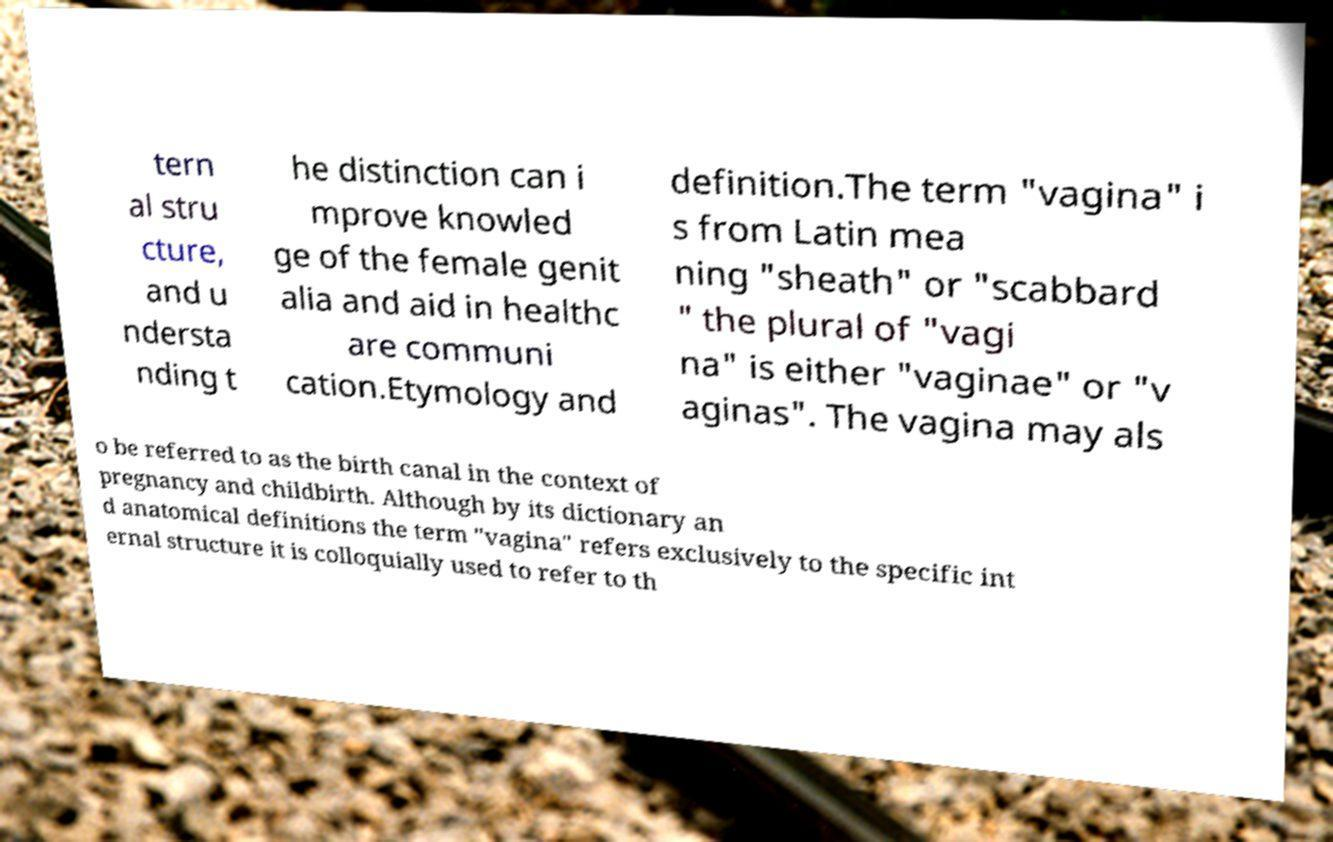What messages or text are displayed in this image? I need them in a readable, typed format. tern al stru cture, and u ndersta nding t he distinction can i mprove knowled ge of the female genit alia and aid in healthc are communi cation.Etymology and definition.The term "vagina" i s from Latin mea ning "sheath" or "scabbard " the plural of "vagi na" is either "vaginae" or "v aginas". The vagina may als o be referred to as the birth canal in the context of pregnancy and childbirth. Although by its dictionary an d anatomical definitions the term "vagina" refers exclusively to the specific int ernal structure it is colloquially used to refer to th 